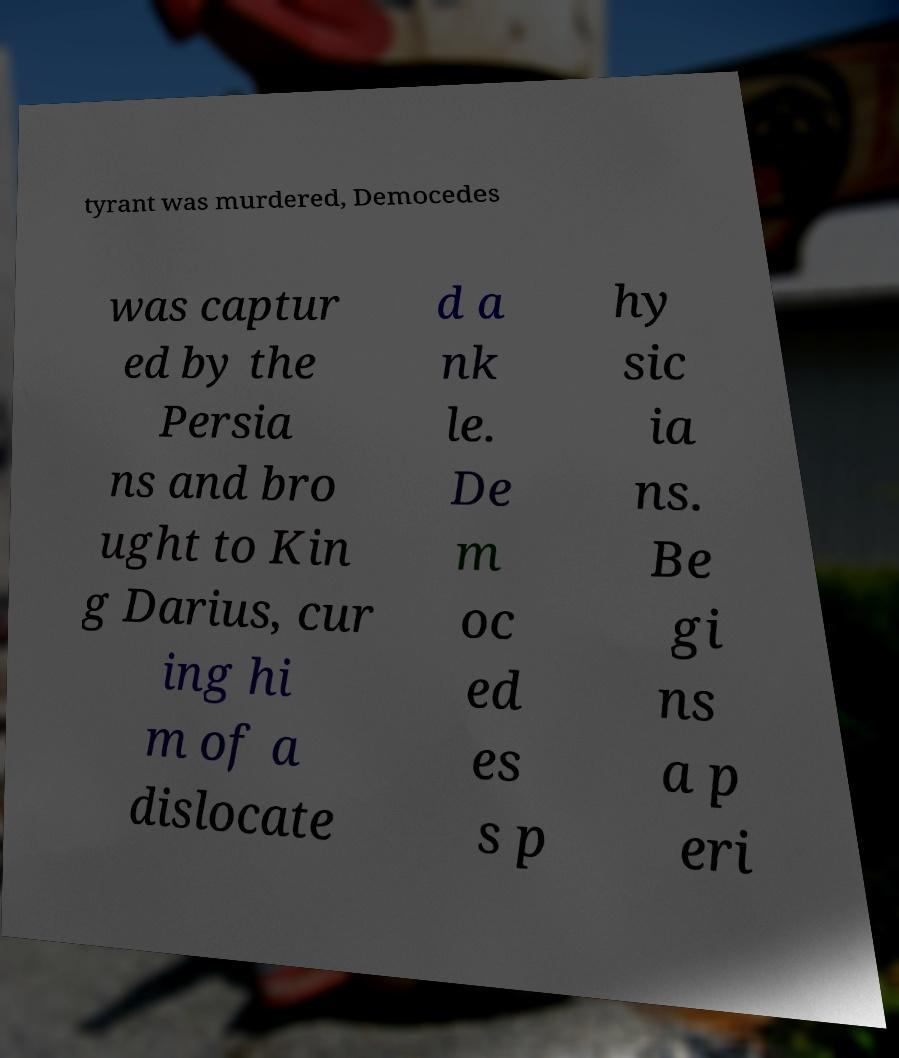I need the written content from this picture converted into text. Can you do that? tyrant was murdered, Democedes was captur ed by the Persia ns and bro ught to Kin g Darius, cur ing hi m of a dislocate d a nk le. De m oc ed es s p hy sic ia ns. Be gi ns a p eri 